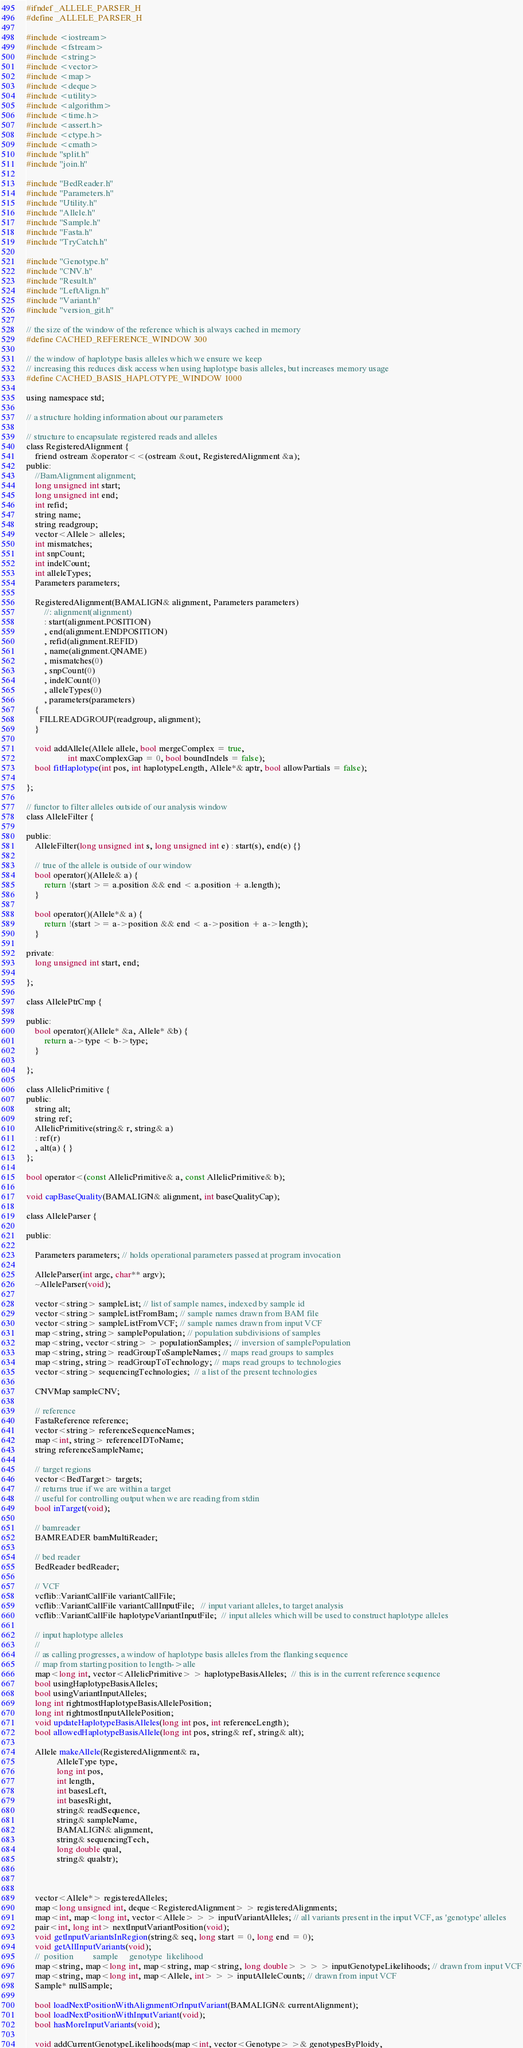Convert code to text. <code><loc_0><loc_0><loc_500><loc_500><_C_>#ifndef _ALLELE_PARSER_H
#define _ALLELE_PARSER_H

#include <iostream>
#include <fstream>
#include <string>
#include <vector>
#include <map>
#include <deque>
#include <utility>
#include <algorithm>
#include <time.h>
#include <assert.h>
#include <ctype.h>
#include <cmath>
#include "split.h"
#include "join.h"

#include "BedReader.h"
#include "Parameters.h"
#include "Utility.h"
#include "Allele.h"
#include "Sample.h"
#include "Fasta.h"
#include "TryCatch.h"

#include "Genotype.h"
#include "CNV.h"
#include "Result.h"
#include "LeftAlign.h"
#include "Variant.h"
#include "version_git.h"

// the size of the window of the reference which is always cached in memory
#define CACHED_REFERENCE_WINDOW 300

// the window of haplotype basis alleles which we ensure we keep
// increasing this reduces disk access when using haplotype basis alleles, but increases memory usage
#define CACHED_BASIS_HAPLOTYPE_WINDOW 1000

using namespace std;

// a structure holding information about our parameters

// structure to encapsulate registered reads and alleles
class RegisteredAlignment {
    friend ostream &operator<<(ostream &out, RegisteredAlignment &a);
public:
    //BamAlignment alignment;
    long unsigned int start;
    long unsigned int end;
    int refid;
    string name;
    string readgroup;
    vector<Allele> alleles;
    int mismatches;
    int snpCount;
    int indelCount;
    int alleleTypes;
    Parameters parameters;

    RegisteredAlignment(BAMALIGN& alignment, Parameters parameters)
        //: alignment(alignment)
        : start(alignment.POSITION)
        , end(alignment.ENDPOSITION)
        , refid(alignment.REFID)
        , name(alignment.QNAME)
        , mismatches(0)
        , snpCount(0)
        , indelCount(0)
        , alleleTypes(0)
        , parameters(parameters)
    {
      FILLREADGROUP(readgroup, alignment);
    }

    void addAllele(Allele allele, bool mergeComplex = true,
                   int maxComplexGap = 0, bool boundIndels = false);
    bool fitHaplotype(int pos, int haplotypeLength, Allele*& aptr, bool allowPartials = false);

};

// functor to filter alleles outside of our analysis window
class AlleleFilter {

public:
    AlleleFilter(long unsigned int s, long unsigned int e) : start(s), end(e) {}

    // true of the allele is outside of our window
    bool operator()(Allele& a) {
        return !(start >= a.position && end < a.position + a.length);
    }

    bool operator()(Allele*& a) {
        return !(start >= a->position && end < a->position + a->length);
    }

private:
    long unsigned int start, end;

};

class AllelePtrCmp {

public:
    bool operator()(Allele* &a, Allele* &b) {
        return a->type < b->type;
    }

};

class AllelicPrimitive {
public:
    string alt;
    string ref;
    AllelicPrimitive(string& r, string& a)
	: ref(r)
	, alt(a) { }
};

bool operator<(const AllelicPrimitive& a, const AllelicPrimitive& b);

void capBaseQuality(BAMALIGN& alignment, int baseQualityCap);

class AlleleParser {

public:

    Parameters parameters; // holds operational parameters passed at program invocation

    AlleleParser(int argc, char** argv);
    ~AlleleParser(void);

    vector<string> sampleList; // list of sample names, indexed by sample id
    vector<string> sampleListFromBam; // sample names drawn from BAM file
    vector<string> sampleListFromVCF; // sample names drawn from input VCF
    map<string, string> samplePopulation; // population subdivisions of samples
    map<string, vector<string> > populationSamples; // inversion of samplePopulation
    map<string, string> readGroupToSampleNames; // maps read groups to samples
    map<string, string> readGroupToTechnology; // maps read groups to technologies
    vector<string> sequencingTechnologies;  // a list of the present technologies

    CNVMap sampleCNV;

    // reference
    FastaReference reference;
    vector<string> referenceSequenceNames;
    map<int, string> referenceIDToName;
    string referenceSampleName;

    // target regions
    vector<BedTarget> targets;
    // returns true if we are within a target
    // useful for controlling output when we are reading from stdin
    bool inTarget(void);

    // bamreader
    BAMREADER bamMultiReader;

    // bed reader
    BedReader bedReader;

    // VCF
    vcflib::VariantCallFile variantCallFile;
    vcflib::VariantCallFile variantCallInputFile;   // input variant alleles, to target analysis
    vcflib::VariantCallFile haplotypeVariantInputFile;  // input alleles which will be used to construct haplotype alleles

    // input haplotype alleles
    //
    // as calling progresses, a window of haplotype basis alleles from the flanking sequence
    // map from starting position to length->alle
    map<long int, vector<AllelicPrimitive> > haplotypeBasisAlleles;  // this is in the current reference sequence
    bool usingHaplotypeBasisAlleles;
    bool usingVariantInputAlleles;
    long int rightmostHaplotypeBasisAllelePosition;
    long int rightmostInputAllelePosition;
    void updateHaplotypeBasisAlleles(long int pos, int referenceLength);
    bool allowedHaplotypeBasisAllele(long int pos, string& ref, string& alt);

    Allele makeAllele(RegisteredAlignment& ra,
		      AlleleType type,
		      long int pos,
		      int length,
		      int basesLeft,
		      int basesRight,
		      string& readSequence,
		      string& sampleName,
		      BAMALIGN& alignment,
		      string& sequencingTech,
		      long double qual,
		      string& qualstr);



    vector<Allele*> registeredAlleles;
    map<long unsigned int, deque<RegisteredAlignment> > registeredAlignments;
    map<int, map<long int, vector<Allele> > > inputVariantAlleles; // all variants present in the input VCF, as 'genotype' alleles
    pair<int, long int> nextInputVariantPosition(void);
    void getInputVariantsInRegion(string& seq, long start = 0, long end = 0);
    void getAllInputVariants(void);
    //  position         sample     genotype  likelihood
    map<string, map<long int, map<string, map<string, long double> > > > inputGenotypeLikelihoods; // drawn from input VCF
    map<string, map<long int, map<Allele, int> > > inputAlleleCounts; // drawn from input VCF
    Sample* nullSample;

    bool loadNextPositionWithAlignmentOrInputVariant(BAMALIGN& currentAlignment);
    bool loadNextPositionWithInputVariant(void);
    bool hasMoreInputVariants(void);

    void addCurrentGenotypeLikelihoods(map<int, vector<Genotype> >& genotypesByPloidy,</code> 